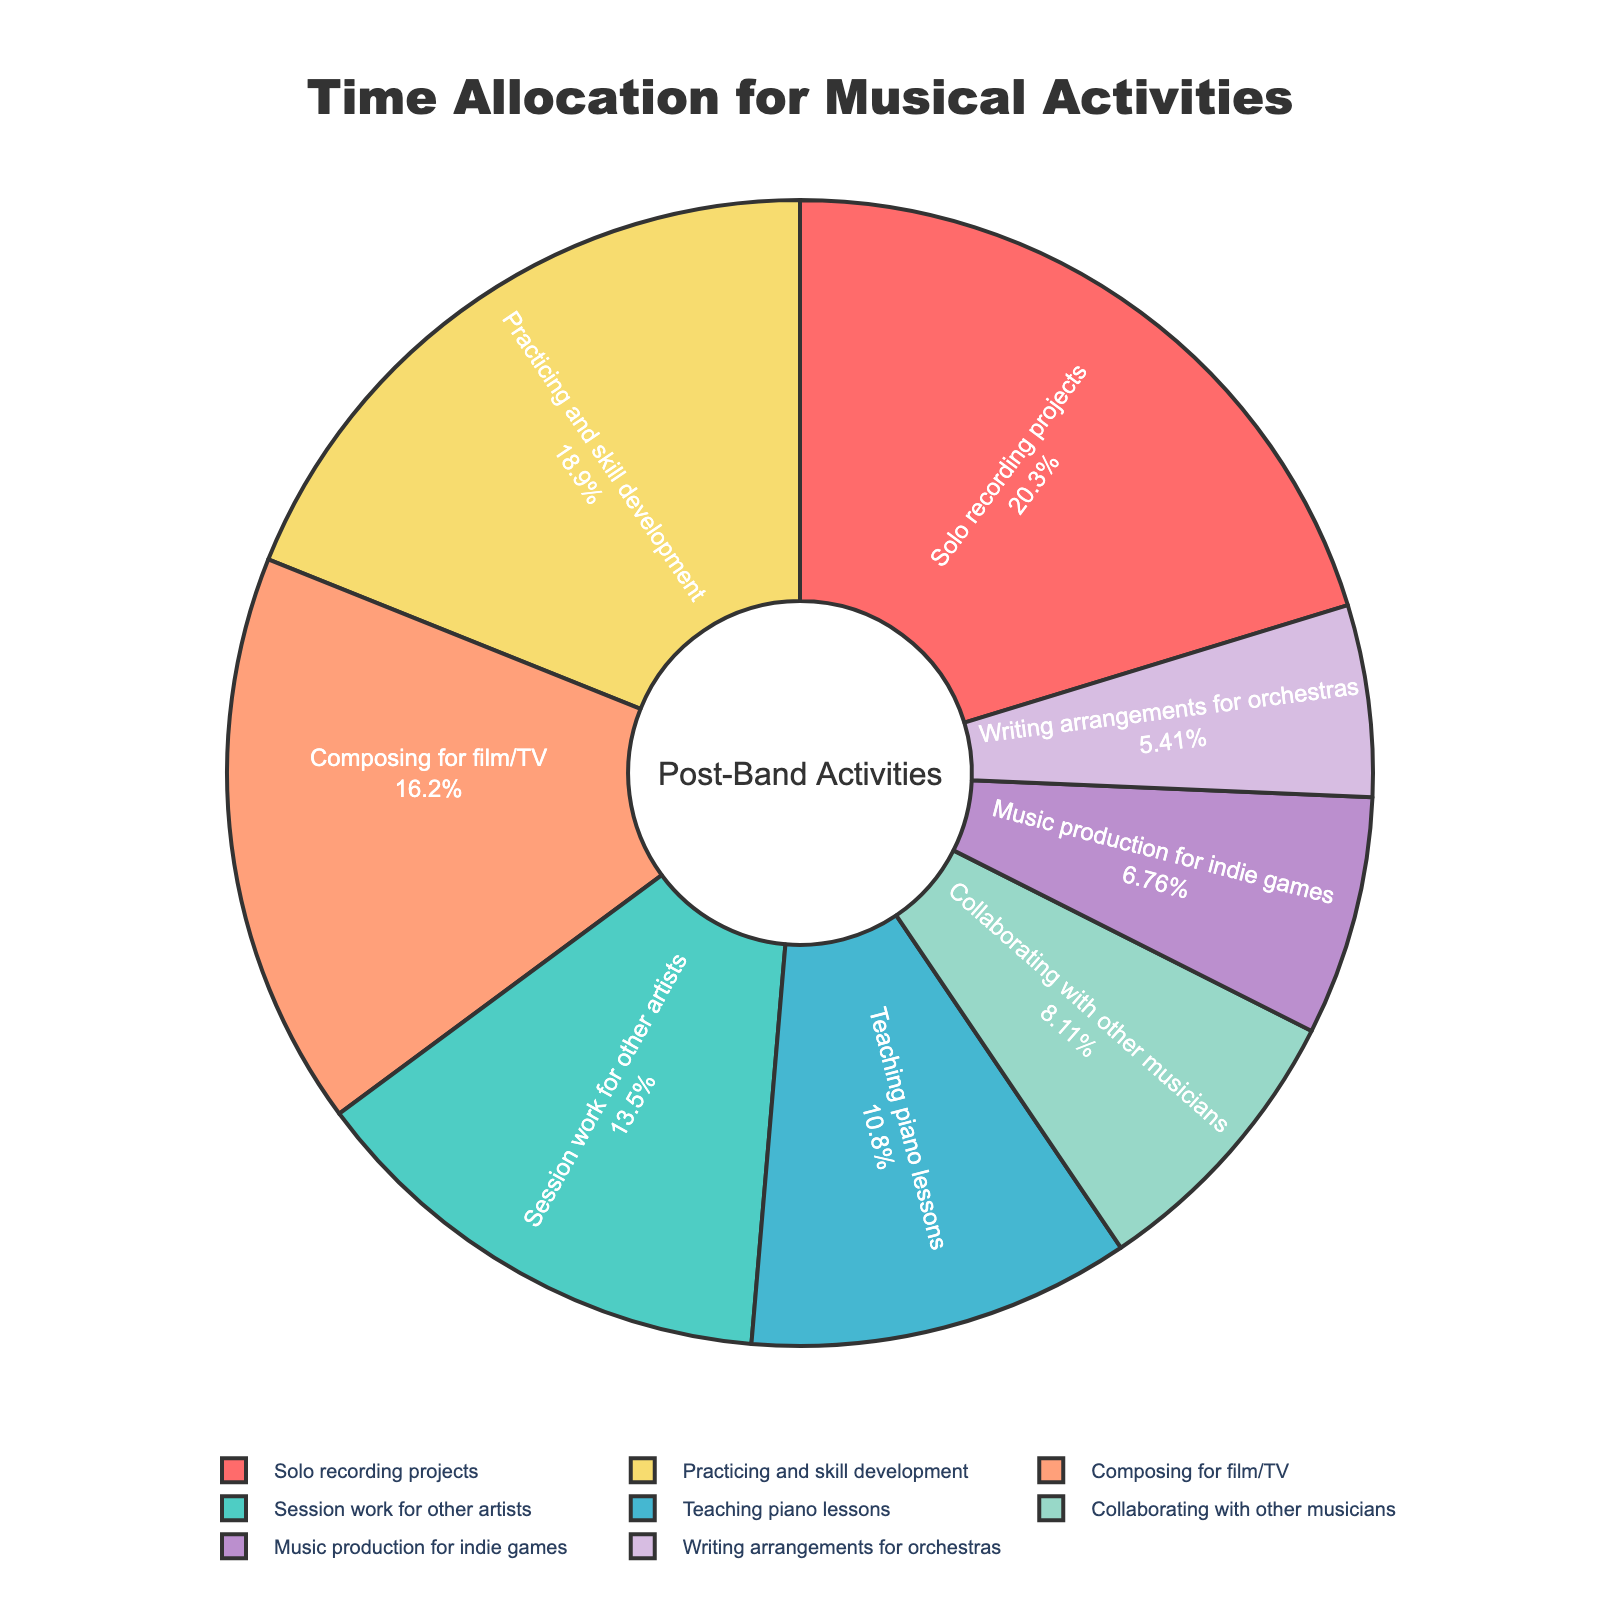Which activity takes up the most time in your schedule? To find the activity that takes up the most time, we look at the segment of the pie chart with the largest percentage. This corresponds to the "Solo recording projects" segment.
Answer: Solo recording projects What percentage of your time is spent on teaching piano lessons? To determine the percentage, look for the "Teaching piano lessons" segment in the pie chart and read the corresponding percentage shown.
Answer: 16% How does the time spent on composing for film/TV compare to session work for other artists? The pie chart indicates segments for both activities. Find and compare their percentages; "Composing for film/TV" is 24% while "Session work for other artists" is 20%.
Answer: Composing for film/TV is more What is the combined percentage of time spent on solo projects and practicing and skill development? To find the combined percentage, simply add the percentages from the segments of "Solo recording projects" and "Practicing and skill development". Those are 30% and 28%, respectively.
Answer: 58% Which activity has the smallest percentage of your time allocation? Look at the pie chart to identify the smallest segment, which corresponds to "Writing arrangements for orchestras".
Answer: Writing arrangements for orchestras What is the difference in time spent between music production for indie games and collaborating with other musicians? Compare the percentages for both activities; "Music production for indie games" is 10%, and "Collaborating with other musicians" is 12%. The difference is 12% - 10%.
Answer: 2% Arrange the activities in descending order of time spent. Read the percentages of all activities from the pie chart and arrange them from highest to lowest. The order is: Solo recording projects, Practicing and skill development, Composing for film/TV, Session work for other artists, Teaching piano lessons, Collaborating with other musicians, Music production for indie games, Writing arrangements for orchestras.
Answer: Solo recording projects, Practicing and skill development, Composing for film/TV, Session work for other artists, Teaching piano lessons, Collaborating with other musicians, Music production for indie games, Writing arrangements for orchestras What is the total time spent on teaching and composing activities combined? First, identify the percentages for "Teaching piano lessons" (16%) and "Composing for film/TV" (24%) from the pie chart. Add these percentages together.
Answer: 40% 